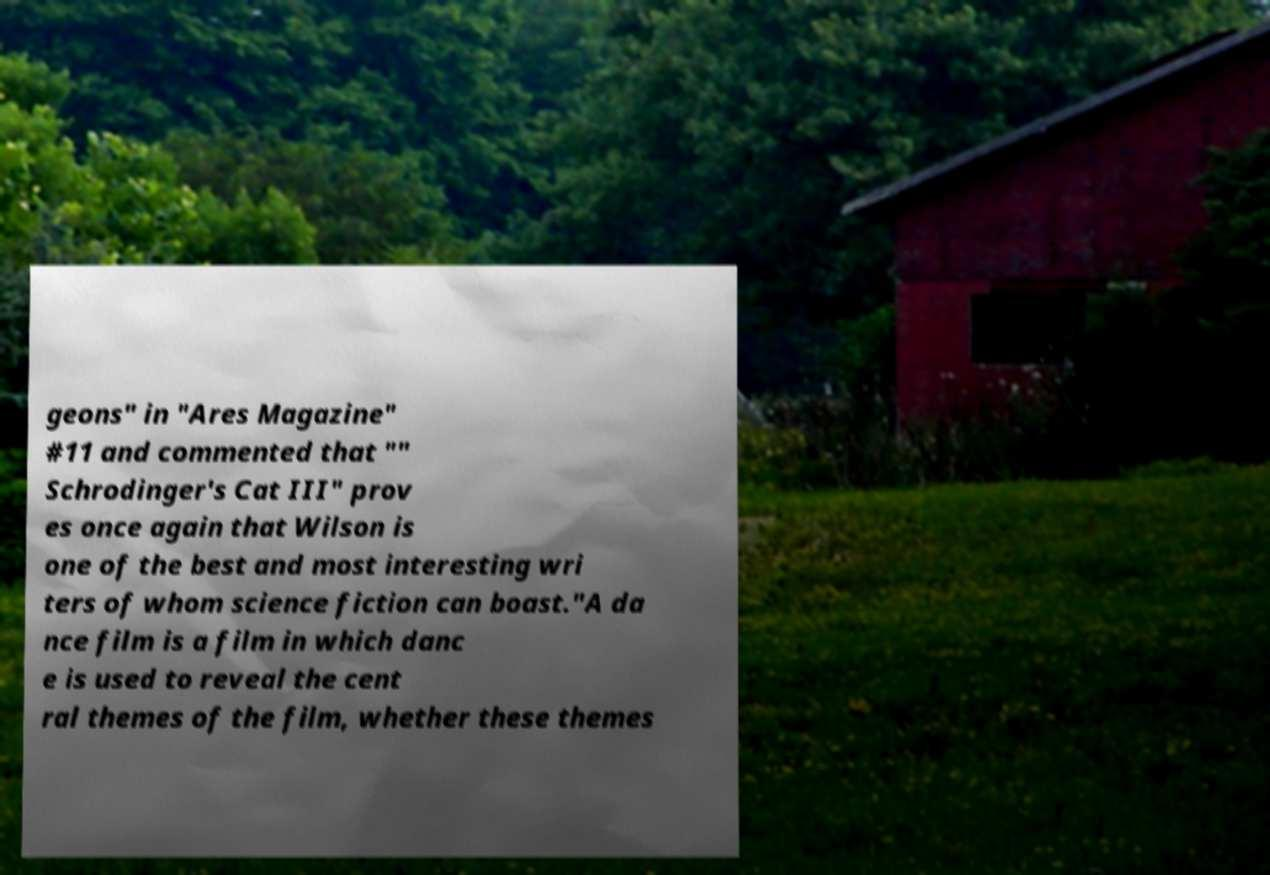Could you assist in decoding the text presented in this image and type it out clearly? geons" in "Ares Magazine" #11 and commented that "" Schrodinger's Cat III" prov es once again that Wilson is one of the best and most interesting wri ters of whom science fiction can boast."A da nce film is a film in which danc e is used to reveal the cent ral themes of the film, whether these themes 